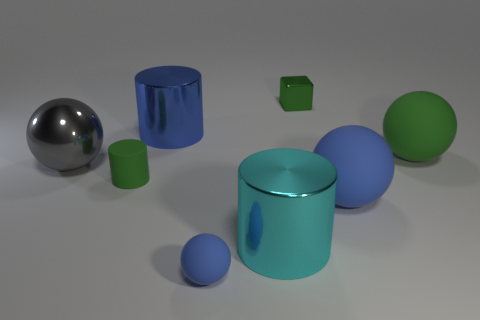Is there anything else that is made of the same material as the large blue cylinder?
Your response must be concise. Yes. What number of cyan cylinders are on the left side of the green rubber object that is behind the rubber object that is on the left side of the tiny blue sphere?
Offer a terse response. 1. What is the size of the green sphere?
Your response must be concise. Large. Is the color of the matte cylinder the same as the tiny metal object?
Give a very brief answer. Yes. What size is the green rubber object that is right of the cube?
Give a very brief answer. Large. Do the big metal cylinder in front of the big gray metallic ball and the metallic cylinder that is left of the tiny blue matte ball have the same color?
Offer a terse response. No. How many other things are there of the same shape as the big cyan thing?
Provide a short and direct response. 2. Are there an equal number of big balls left of the small blue rubber object and large gray things that are in front of the small cylinder?
Your answer should be very brief. No. Does the blue sphere that is behind the tiny ball have the same material as the blue thing that is behind the large gray object?
Provide a short and direct response. No. What number of other objects are there of the same size as the green block?
Provide a succinct answer. 2. 